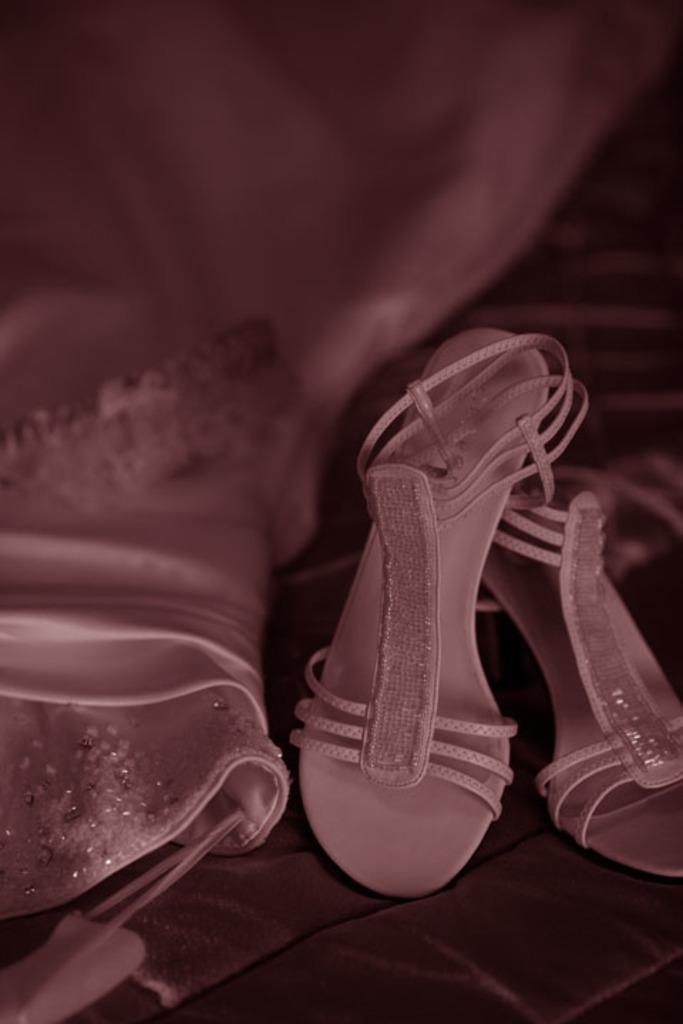What type of footwear is present in the image? There is pink footwear in the image. What is the color of the dress next to the footwear? There is a matching color dress beside the footwear. What rule is being enforced by the footwear in the image? There is no rule being enforced by the footwear in the image; it is simply a piece of footwear. What caption would best describe the image? The image does not have a caption, so it cannot be determined what caption would best describe it. 